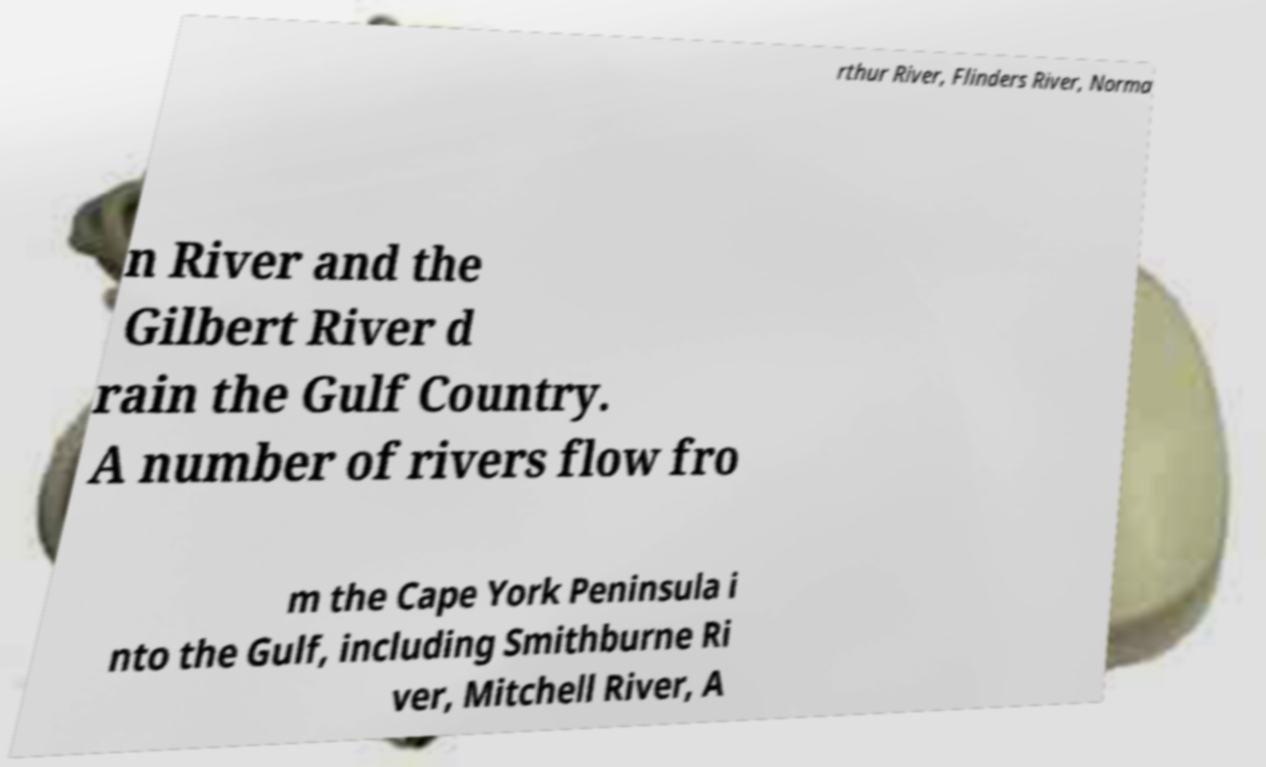Please read and relay the text visible in this image. What does it say? rthur River, Flinders River, Norma n River and the Gilbert River d rain the Gulf Country. A number of rivers flow fro m the Cape York Peninsula i nto the Gulf, including Smithburne Ri ver, Mitchell River, A 